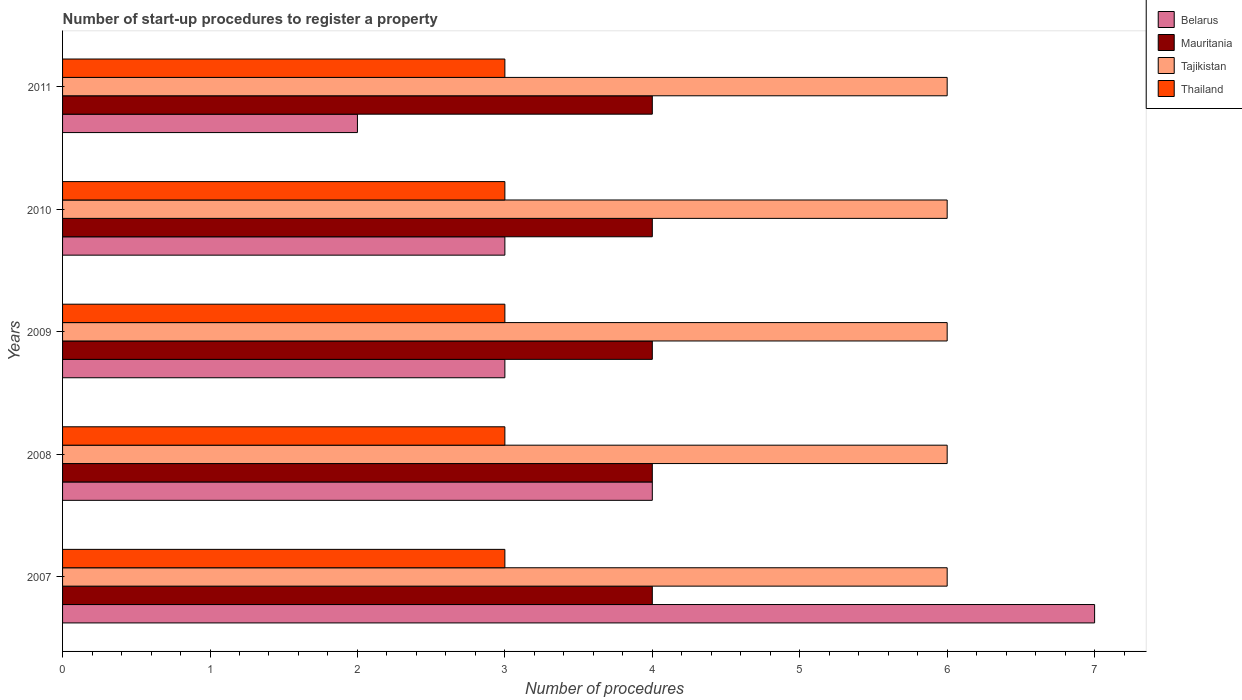Are the number of bars on each tick of the Y-axis equal?
Provide a succinct answer. Yes. How many bars are there on the 3rd tick from the top?
Your answer should be compact. 4. What is the label of the 5th group of bars from the top?
Offer a very short reply. 2007. Across all years, what is the maximum number of procedures required to register a property in Thailand?
Your answer should be very brief. 3. Across all years, what is the minimum number of procedures required to register a property in Mauritania?
Make the answer very short. 4. In which year was the number of procedures required to register a property in Belarus maximum?
Keep it short and to the point. 2007. What is the total number of procedures required to register a property in Mauritania in the graph?
Your response must be concise. 20. What is the difference between the number of procedures required to register a property in Belarus in 2008 and that in 2011?
Your response must be concise. 2. What is the difference between the number of procedures required to register a property in Thailand in 2011 and the number of procedures required to register a property in Belarus in 2007?
Ensure brevity in your answer.  -4. What is the average number of procedures required to register a property in Belarus per year?
Ensure brevity in your answer.  3.8. In the year 2007, what is the difference between the number of procedures required to register a property in Mauritania and number of procedures required to register a property in Tajikistan?
Give a very brief answer. -2. What is the ratio of the number of procedures required to register a property in Belarus in 2007 to that in 2010?
Your answer should be very brief. 2.33. What is the difference between the highest and the lowest number of procedures required to register a property in Thailand?
Your answer should be very brief. 0. What does the 4th bar from the top in 2011 represents?
Offer a very short reply. Belarus. What does the 1st bar from the bottom in 2009 represents?
Offer a terse response. Belarus. How many bars are there?
Give a very brief answer. 20. Are all the bars in the graph horizontal?
Offer a very short reply. Yes. What is the difference between two consecutive major ticks on the X-axis?
Keep it short and to the point. 1. Does the graph contain any zero values?
Provide a short and direct response. No. Does the graph contain grids?
Your answer should be very brief. No. Where does the legend appear in the graph?
Keep it short and to the point. Top right. What is the title of the graph?
Keep it short and to the point. Number of start-up procedures to register a property. What is the label or title of the X-axis?
Keep it short and to the point. Number of procedures. What is the Number of procedures of Belarus in 2007?
Your answer should be compact. 7. What is the Number of procedures of Tajikistan in 2007?
Provide a short and direct response. 6. What is the Number of procedures of Thailand in 2007?
Provide a short and direct response. 3. What is the Number of procedures in Belarus in 2008?
Provide a succinct answer. 4. What is the Number of procedures in Mauritania in 2008?
Offer a very short reply. 4. What is the Number of procedures in Tajikistan in 2008?
Give a very brief answer. 6. What is the Number of procedures in Thailand in 2008?
Your answer should be compact. 3. What is the Number of procedures in Belarus in 2009?
Ensure brevity in your answer.  3. What is the Number of procedures of Thailand in 2009?
Keep it short and to the point. 3. What is the Number of procedures of Belarus in 2010?
Your response must be concise. 3. What is the Number of procedures in Tajikistan in 2010?
Offer a terse response. 6. What is the Number of procedures of Tajikistan in 2011?
Make the answer very short. 6. Across all years, what is the maximum Number of procedures of Tajikistan?
Your answer should be compact. 6. Across all years, what is the maximum Number of procedures of Thailand?
Offer a terse response. 3. Across all years, what is the minimum Number of procedures of Belarus?
Make the answer very short. 2. Across all years, what is the minimum Number of procedures of Mauritania?
Offer a very short reply. 4. Across all years, what is the minimum Number of procedures in Tajikistan?
Keep it short and to the point. 6. What is the total Number of procedures of Belarus in the graph?
Give a very brief answer. 19. What is the total Number of procedures in Tajikistan in the graph?
Provide a short and direct response. 30. What is the difference between the Number of procedures of Tajikistan in 2007 and that in 2008?
Ensure brevity in your answer.  0. What is the difference between the Number of procedures of Thailand in 2007 and that in 2008?
Ensure brevity in your answer.  0. What is the difference between the Number of procedures of Belarus in 2007 and that in 2009?
Provide a succinct answer. 4. What is the difference between the Number of procedures in Mauritania in 2007 and that in 2009?
Make the answer very short. 0. What is the difference between the Number of procedures in Tajikistan in 2007 and that in 2009?
Offer a terse response. 0. What is the difference between the Number of procedures in Thailand in 2007 and that in 2009?
Provide a succinct answer. 0. What is the difference between the Number of procedures in Belarus in 2007 and that in 2010?
Offer a terse response. 4. What is the difference between the Number of procedures in Tajikistan in 2007 and that in 2010?
Offer a very short reply. 0. What is the difference between the Number of procedures of Belarus in 2007 and that in 2011?
Make the answer very short. 5. What is the difference between the Number of procedures of Mauritania in 2007 and that in 2011?
Offer a very short reply. 0. What is the difference between the Number of procedures in Tajikistan in 2007 and that in 2011?
Your answer should be very brief. 0. What is the difference between the Number of procedures of Belarus in 2008 and that in 2009?
Offer a very short reply. 1. What is the difference between the Number of procedures in Mauritania in 2008 and that in 2009?
Keep it short and to the point. 0. What is the difference between the Number of procedures of Tajikistan in 2008 and that in 2009?
Provide a short and direct response. 0. What is the difference between the Number of procedures of Thailand in 2008 and that in 2009?
Ensure brevity in your answer.  0. What is the difference between the Number of procedures in Mauritania in 2008 and that in 2010?
Give a very brief answer. 0. What is the difference between the Number of procedures in Thailand in 2008 and that in 2010?
Give a very brief answer. 0. What is the difference between the Number of procedures of Mauritania in 2008 and that in 2011?
Ensure brevity in your answer.  0. What is the difference between the Number of procedures in Tajikistan in 2008 and that in 2011?
Keep it short and to the point. 0. What is the difference between the Number of procedures of Tajikistan in 2009 and that in 2010?
Provide a succinct answer. 0. What is the difference between the Number of procedures in Belarus in 2009 and that in 2011?
Your answer should be compact. 1. What is the difference between the Number of procedures of Mauritania in 2009 and that in 2011?
Offer a terse response. 0. What is the difference between the Number of procedures of Belarus in 2010 and that in 2011?
Your answer should be very brief. 1. What is the difference between the Number of procedures in Thailand in 2010 and that in 2011?
Your response must be concise. 0. What is the difference between the Number of procedures of Belarus in 2007 and the Number of procedures of Mauritania in 2008?
Provide a short and direct response. 3. What is the difference between the Number of procedures in Belarus in 2007 and the Number of procedures in Tajikistan in 2008?
Your answer should be compact. 1. What is the difference between the Number of procedures in Belarus in 2007 and the Number of procedures in Thailand in 2009?
Offer a terse response. 4. What is the difference between the Number of procedures of Mauritania in 2007 and the Number of procedures of Tajikistan in 2009?
Your response must be concise. -2. What is the difference between the Number of procedures of Mauritania in 2007 and the Number of procedures of Thailand in 2009?
Keep it short and to the point. 1. What is the difference between the Number of procedures in Belarus in 2007 and the Number of procedures in Thailand in 2010?
Your response must be concise. 4. What is the difference between the Number of procedures in Belarus in 2007 and the Number of procedures in Thailand in 2011?
Keep it short and to the point. 4. What is the difference between the Number of procedures of Mauritania in 2007 and the Number of procedures of Thailand in 2011?
Your answer should be compact. 1. What is the difference between the Number of procedures in Belarus in 2008 and the Number of procedures in Mauritania in 2009?
Your answer should be compact. 0. What is the difference between the Number of procedures in Belarus in 2008 and the Number of procedures in Tajikistan in 2009?
Ensure brevity in your answer.  -2. What is the difference between the Number of procedures in Belarus in 2008 and the Number of procedures in Thailand in 2009?
Your answer should be compact. 1. What is the difference between the Number of procedures of Belarus in 2008 and the Number of procedures of Mauritania in 2010?
Provide a short and direct response. 0. What is the difference between the Number of procedures in Mauritania in 2008 and the Number of procedures in Thailand in 2010?
Your response must be concise. 1. What is the difference between the Number of procedures in Belarus in 2008 and the Number of procedures in Tajikistan in 2011?
Give a very brief answer. -2. What is the difference between the Number of procedures in Belarus in 2008 and the Number of procedures in Thailand in 2011?
Keep it short and to the point. 1. What is the difference between the Number of procedures of Mauritania in 2008 and the Number of procedures of Tajikistan in 2011?
Give a very brief answer. -2. What is the difference between the Number of procedures of Tajikistan in 2008 and the Number of procedures of Thailand in 2011?
Offer a terse response. 3. What is the difference between the Number of procedures in Belarus in 2009 and the Number of procedures in Mauritania in 2010?
Provide a succinct answer. -1. What is the difference between the Number of procedures in Mauritania in 2009 and the Number of procedures in Tajikistan in 2010?
Provide a short and direct response. -2. What is the difference between the Number of procedures of Mauritania in 2009 and the Number of procedures of Thailand in 2010?
Provide a short and direct response. 1. What is the difference between the Number of procedures of Belarus in 2009 and the Number of procedures of Mauritania in 2011?
Give a very brief answer. -1. What is the difference between the Number of procedures in Belarus in 2009 and the Number of procedures in Tajikistan in 2011?
Offer a very short reply. -3. What is the difference between the Number of procedures of Belarus in 2009 and the Number of procedures of Thailand in 2011?
Your answer should be very brief. 0. What is the difference between the Number of procedures in Mauritania in 2009 and the Number of procedures in Tajikistan in 2011?
Offer a very short reply. -2. What is the difference between the Number of procedures in Mauritania in 2009 and the Number of procedures in Thailand in 2011?
Offer a terse response. 1. What is the average Number of procedures in Belarus per year?
Your answer should be compact. 3.8. What is the average Number of procedures in Tajikistan per year?
Provide a short and direct response. 6. What is the average Number of procedures in Thailand per year?
Make the answer very short. 3. In the year 2007, what is the difference between the Number of procedures of Belarus and Number of procedures of Thailand?
Give a very brief answer. 4. In the year 2007, what is the difference between the Number of procedures in Mauritania and Number of procedures in Tajikistan?
Give a very brief answer. -2. In the year 2007, what is the difference between the Number of procedures of Mauritania and Number of procedures of Thailand?
Offer a very short reply. 1. In the year 2008, what is the difference between the Number of procedures of Belarus and Number of procedures of Mauritania?
Your answer should be very brief. 0. In the year 2008, what is the difference between the Number of procedures in Belarus and Number of procedures in Tajikistan?
Offer a very short reply. -2. In the year 2008, what is the difference between the Number of procedures of Belarus and Number of procedures of Thailand?
Keep it short and to the point. 1. In the year 2008, what is the difference between the Number of procedures of Tajikistan and Number of procedures of Thailand?
Provide a succinct answer. 3. In the year 2009, what is the difference between the Number of procedures of Belarus and Number of procedures of Thailand?
Make the answer very short. 0. In the year 2009, what is the difference between the Number of procedures in Mauritania and Number of procedures in Thailand?
Offer a terse response. 1. In the year 2010, what is the difference between the Number of procedures of Belarus and Number of procedures of Mauritania?
Offer a very short reply. -1. In the year 2010, what is the difference between the Number of procedures in Belarus and Number of procedures in Thailand?
Provide a short and direct response. 0. In the year 2010, what is the difference between the Number of procedures of Tajikistan and Number of procedures of Thailand?
Keep it short and to the point. 3. In the year 2011, what is the difference between the Number of procedures of Belarus and Number of procedures of Tajikistan?
Your answer should be compact. -4. In the year 2011, what is the difference between the Number of procedures of Tajikistan and Number of procedures of Thailand?
Provide a short and direct response. 3. What is the ratio of the Number of procedures in Mauritania in 2007 to that in 2008?
Your answer should be very brief. 1. What is the ratio of the Number of procedures in Belarus in 2007 to that in 2009?
Give a very brief answer. 2.33. What is the ratio of the Number of procedures in Mauritania in 2007 to that in 2009?
Your answer should be very brief. 1. What is the ratio of the Number of procedures of Tajikistan in 2007 to that in 2009?
Your response must be concise. 1. What is the ratio of the Number of procedures in Thailand in 2007 to that in 2009?
Offer a terse response. 1. What is the ratio of the Number of procedures of Belarus in 2007 to that in 2010?
Keep it short and to the point. 2.33. What is the ratio of the Number of procedures in Tajikistan in 2007 to that in 2010?
Your answer should be compact. 1. What is the ratio of the Number of procedures of Mauritania in 2007 to that in 2011?
Make the answer very short. 1. What is the ratio of the Number of procedures of Tajikistan in 2007 to that in 2011?
Your answer should be very brief. 1. What is the ratio of the Number of procedures of Belarus in 2008 to that in 2009?
Offer a very short reply. 1.33. What is the ratio of the Number of procedures of Mauritania in 2008 to that in 2009?
Offer a terse response. 1. What is the ratio of the Number of procedures in Thailand in 2008 to that in 2009?
Provide a short and direct response. 1. What is the ratio of the Number of procedures of Thailand in 2008 to that in 2010?
Keep it short and to the point. 1. What is the ratio of the Number of procedures in Belarus in 2008 to that in 2011?
Keep it short and to the point. 2. What is the ratio of the Number of procedures in Thailand in 2008 to that in 2011?
Keep it short and to the point. 1. What is the ratio of the Number of procedures in Belarus in 2009 to that in 2010?
Provide a succinct answer. 1. What is the ratio of the Number of procedures in Mauritania in 2009 to that in 2010?
Your answer should be very brief. 1. What is the ratio of the Number of procedures of Thailand in 2009 to that in 2010?
Keep it short and to the point. 1. What is the ratio of the Number of procedures of Tajikistan in 2010 to that in 2011?
Ensure brevity in your answer.  1. What is the ratio of the Number of procedures in Thailand in 2010 to that in 2011?
Keep it short and to the point. 1. What is the difference between the highest and the second highest Number of procedures of Belarus?
Provide a short and direct response. 3. What is the difference between the highest and the second highest Number of procedures of Tajikistan?
Provide a succinct answer. 0. What is the difference between the highest and the lowest Number of procedures of Tajikistan?
Keep it short and to the point. 0. 